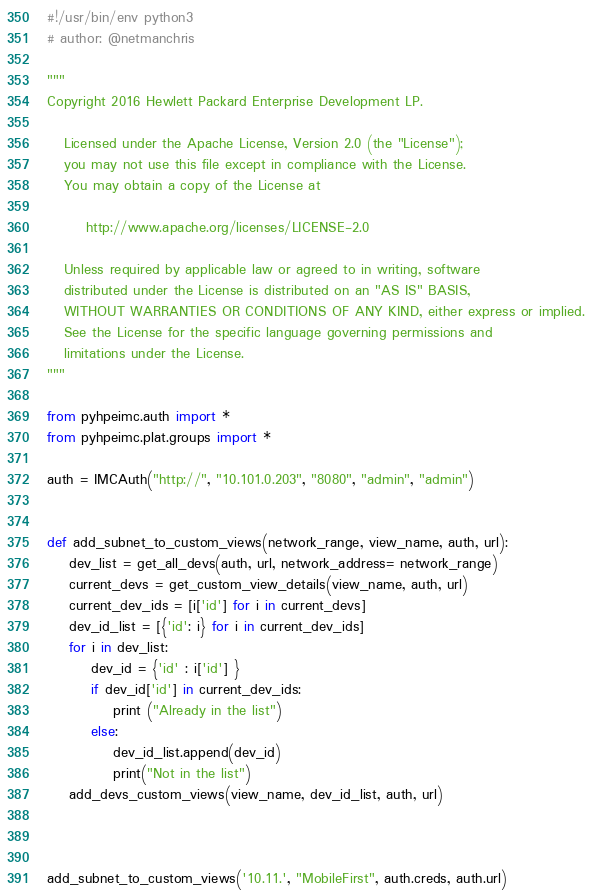Convert code to text. <code><loc_0><loc_0><loc_500><loc_500><_Python_>#!/usr/bin/env python3
# author: @netmanchris

"""
Copyright 2016 Hewlett Packard Enterprise Development LP.

   Licensed under the Apache License, Version 2.0 (the "License");
   you may not use this file except in compliance with the License.
   You may obtain a copy of the License at

       http://www.apache.org/licenses/LICENSE-2.0

   Unless required by applicable law or agreed to in writing, software
   distributed under the License is distributed on an "AS IS" BASIS,
   WITHOUT WARRANTIES OR CONDITIONS OF ANY KIND, either express or implied.
   See the License for the specific language governing permissions and
   limitations under the License.
"""

from pyhpeimc.auth import *
from pyhpeimc.plat.groups import *

auth = IMCAuth("http://", "10.101.0.203", "8080", "admin", "admin")


def add_subnet_to_custom_views(network_range, view_name, auth, url):
    dev_list = get_all_devs(auth, url, network_address= network_range)
    current_devs = get_custom_view_details(view_name, auth, url)
    current_dev_ids = [i['id'] for i in current_devs]
    dev_id_list = [{'id': i} for i in current_dev_ids]
    for i in dev_list:
        dev_id = {'id' : i['id'] }
        if dev_id['id'] in current_dev_ids:
            print ("Already in the list")
        else:
            dev_id_list.append(dev_id)
            print("Not in the list")
    add_devs_custom_views(view_name, dev_id_list, auth, url)



add_subnet_to_custom_views('10.11.', "MobileFirst", auth.creds, auth.url)





</code> 